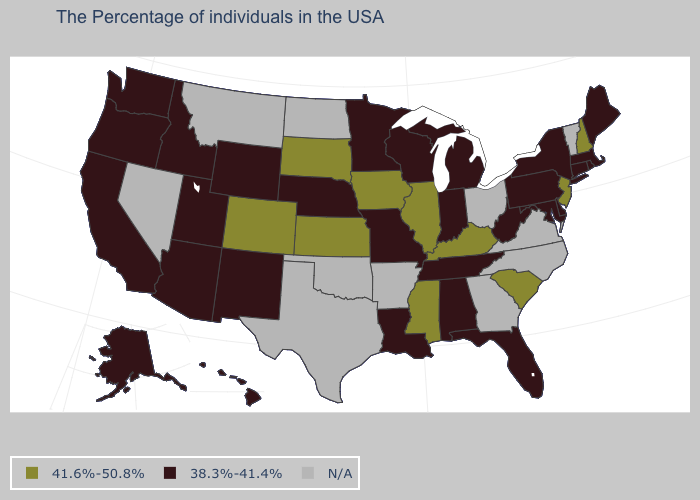Name the states that have a value in the range 38.3%-41.4%?
Keep it brief. Maine, Massachusetts, Rhode Island, Connecticut, New York, Delaware, Maryland, Pennsylvania, West Virginia, Florida, Michigan, Indiana, Alabama, Tennessee, Wisconsin, Louisiana, Missouri, Minnesota, Nebraska, Wyoming, New Mexico, Utah, Arizona, Idaho, California, Washington, Oregon, Alaska, Hawaii. What is the value of Texas?
Write a very short answer. N/A. How many symbols are there in the legend?
Keep it brief. 3. What is the value of California?
Keep it brief. 38.3%-41.4%. Does Wyoming have the highest value in the USA?
Keep it brief. No. What is the highest value in the Northeast ?
Short answer required. 41.6%-50.8%. What is the lowest value in the MidWest?
Concise answer only. 38.3%-41.4%. Name the states that have a value in the range N/A?
Write a very short answer. Vermont, Virginia, North Carolina, Ohio, Georgia, Arkansas, Oklahoma, Texas, North Dakota, Montana, Nevada. Does Kansas have the lowest value in the MidWest?
Answer briefly. No. Does New Hampshire have the highest value in the USA?
Answer briefly. Yes. Name the states that have a value in the range N/A?
Answer briefly. Vermont, Virginia, North Carolina, Ohio, Georgia, Arkansas, Oklahoma, Texas, North Dakota, Montana, Nevada. Does the map have missing data?
Write a very short answer. Yes. What is the value of Kansas?
Give a very brief answer. 41.6%-50.8%. Which states have the lowest value in the MidWest?
Give a very brief answer. Michigan, Indiana, Wisconsin, Missouri, Minnesota, Nebraska. 